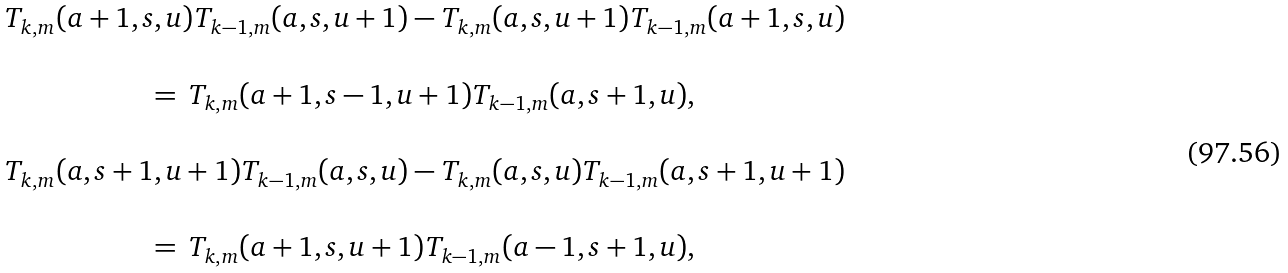Convert formula to latex. <formula><loc_0><loc_0><loc_500><loc_500>\begin{array} { c } T _ { k , m } ( a + 1 , s , u ) T _ { k - 1 , m } ( a , s , u + 1 ) - T _ { k , m } ( a , s , u + 1 ) T _ { k - 1 , m } ( a + 1 , s , u ) \\ \\ = \, T _ { k , m } ( a + 1 , s - 1 , u + 1 ) T _ { k - 1 , m } ( a , s + 1 , u ) , \\ \\ T _ { k , m } ( a , s + 1 , u + 1 ) T _ { k - 1 , m } ( a , s , u ) - T _ { k , m } ( a , s , u ) T _ { k - 1 , m } ( a , s + 1 , u + 1 ) \\ \\ = \, T _ { k , m } ( a + 1 , s , u + 1 ) T _ { k - 1 , m } ( a - 1 , s + 1 , u ) , \\ \\ \end{array}</formula> 